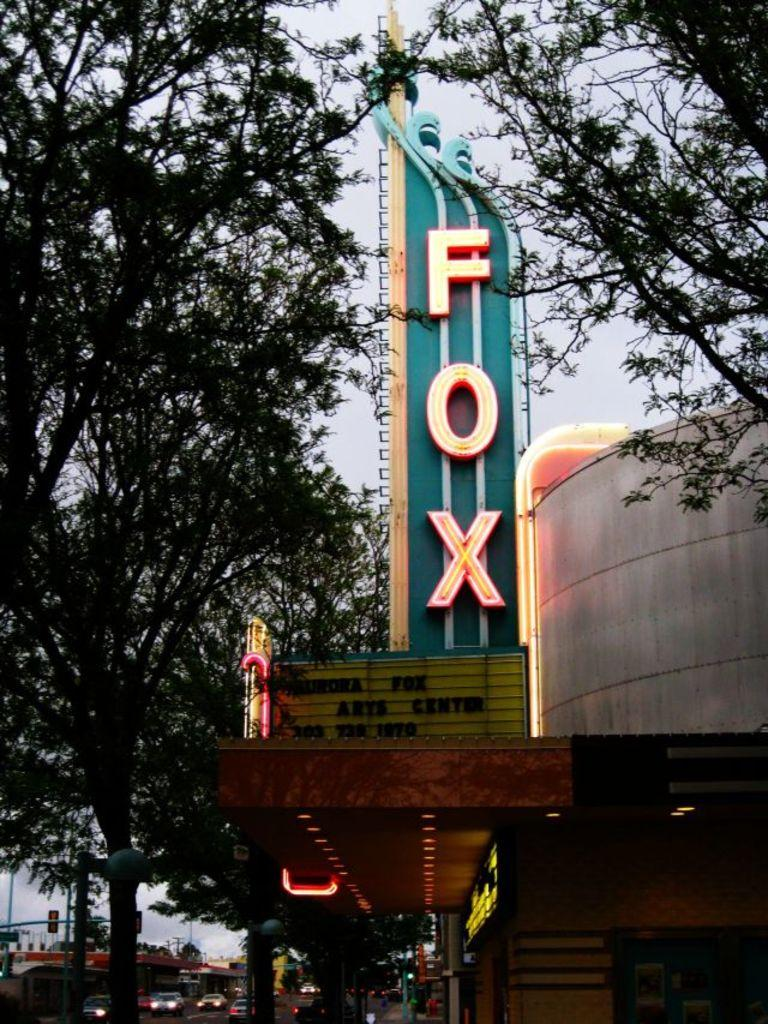What is the main structure visible in the image? There is a hoarding in the image. What type of building can be seen in the image? There is a house in the image. What can be seen illuminating the scene in the image? There are lights in the image. What type of vegetation is present in the image? There are trees in the image. What type of barrier is visible in the image? There is a wall in the image. What type of transportation is visible at the bottom of the image? There are vehicles at the bottom of the image. What type of vertical structures are present in the image? There are poles in the image. What is visible in the background of the image? The sky is visible in the background of the image. Where is the heart-shaped pickle located in the image? There is no heart-shaped pickle present in the image. How many trains can be seen in the image? There are no trains visible in the image. 